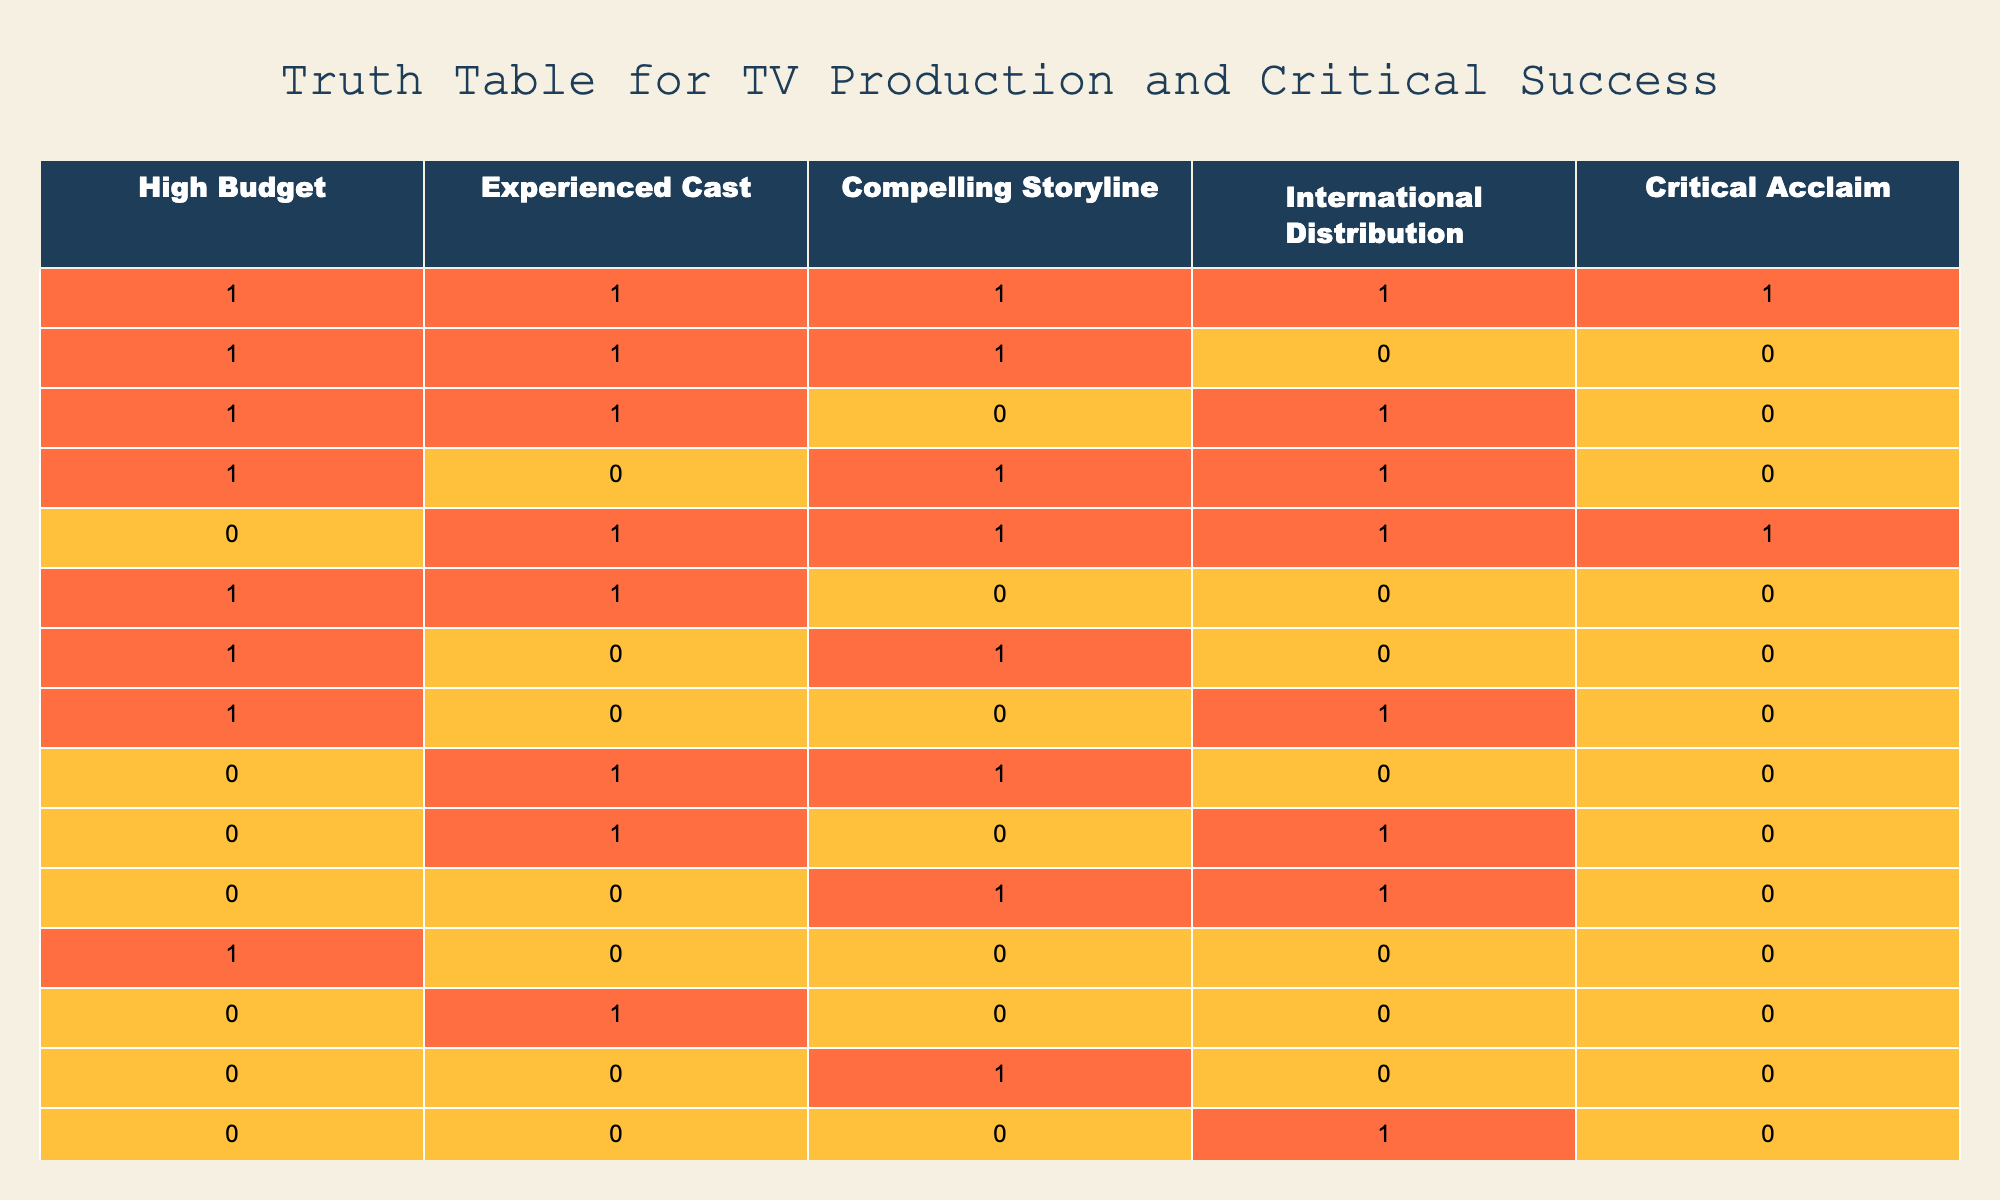What percentage of productions with a compelling storyline received critical acclaim? There are 5 entries with a compelling storyline (1 in the first row, 1 in the second row, and 1 in the fourth row, plus 1 in the fifth row, and 0 in the seventh row). Out of those, only the first entry received critical acclaim. Therefore, the percentage is (1/5) * 100 = 20%.
Answer: 20% How many productions had both international distribution and critical acclaim? Examining the entries, we see that only one row (the first row) had both international distribution (1) and critical acclaim (1). Therefore, the total count is 1.
Answer: 1 Is critical acclaim guaranteed when there is high budget and an experienced cast? From the table, we observe that there are three entries (first, second, and sixth rows) with both high budget and experienced cast (1, 1). However, only the first entry received critical acclaim. Thus, critical acclaim is not guaranteed.
Answer: No What is the total number of productions with an experienced cast? There are 9 entries (rows 1, 2, 5, 6, 8, 10, 12, 13) that have an experienced cast (1). Counting these gives a total of 9 productions.
Answer: 9 What proportion of productions without a high budget had critical acclaim? Of the 8 productions without a high budget (0), only one row (row 5) received critical acclaim. Hence, the proportion is 1 out of 8, which can be expressed as 1/8 = 0.125 or 12.5%.
Answer: 12.5% Do all productions with international distribution also have critical acclaim? Looking at the entries with international distribution (rows 1, 3, 4, 5, 10, 12, and 14), we can see that out of 7 productions, only row 5 received critical acclaim. Thus, not all productions with international distribution are critically acclaimed.
Answer: No What is the total number of productions that did not have a compelling storyline and still received critical acclaim? The only entry that fits this description is row 5, so the total count is 1 production that had neither a compelling storyline nor received acclaim.
Answer: 1 How many productions were made with a high budget and without a compelling storyline? By evaluating the table, we see that rows 2, 6, and 10 had a high budget (1) but did not have a compelling storyline (0). Thus, there are 3 such productions.
Answer: 3 In how many cases does an experienced cast correlate with critical acclaim? Of the rows with an experienced cast (1), only the first and the fifth rows had critical acclaim (1). This gives us a correlation count of 2 instances.
Answer: 2 